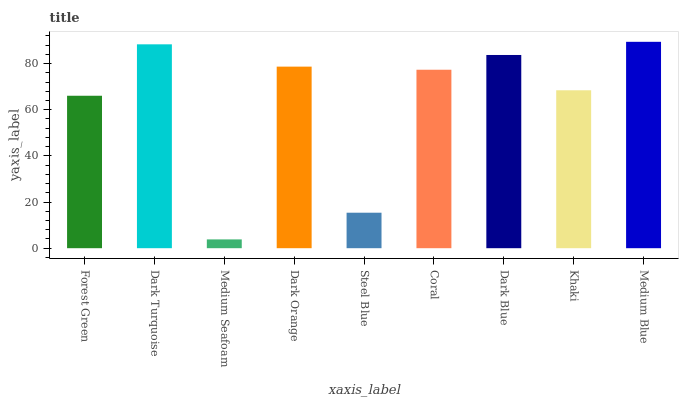Is Dark Turquoise the minimum?
Answer yes or no. No. Is Dark Turquoise the maximum?
Answer yes or no. No. Is Dark Turquoise greater than Forest Green?
Answer yes or no. Yes. Is Forest Green less than Dark Turquoise?
Answer yes or no. Yes. Is Forest Green greater than Dark Turquoise?
Answer yes or no. No. Is Dark Turquoise less than Forest Green?
Answer yes or no. No. Is Coral the high median?
Answer yes or no. Yes. Is Coral the low median?
Answer yes or no. Yes. Is Steel Blue the high median?
Answer yes or no. No. Is Dark Orange the low median?
Answer yes or no. No. 